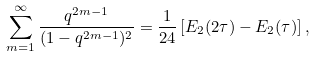Convert formula to latex. <formula><loc_0><loc_0><loc_500><loc_500>\sum _ { m = 1 } ^ { \infty } \frac { q ^ { 2 m - 1 } } { ( 1 - q ^ { 2 m - 1 } ) ^ { 2 } } = \frac { 1 } { 2 4 } \left [ E _ { 2 } ( 2 \tau ) - E _ { 2 } ( \tau ) \right ] ,</formula> 